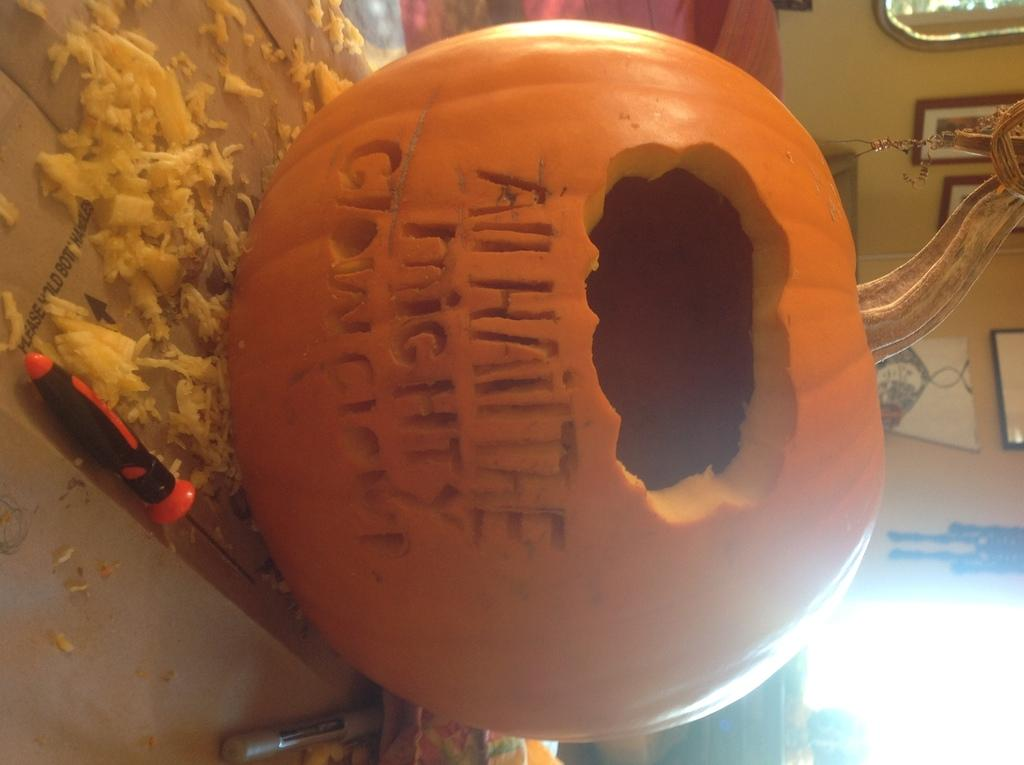What is the main object in the image? There is a pumpkin in the image. What else can be seen in the image besides the pumpkin? There is a tool and objects on the surface visible in the image. What is present on the wall in the background of the image? There are frames on the wall in the background of the image. How many women are present in the image? There is no mention of women in the image, so it cannot be determined how many are present. 